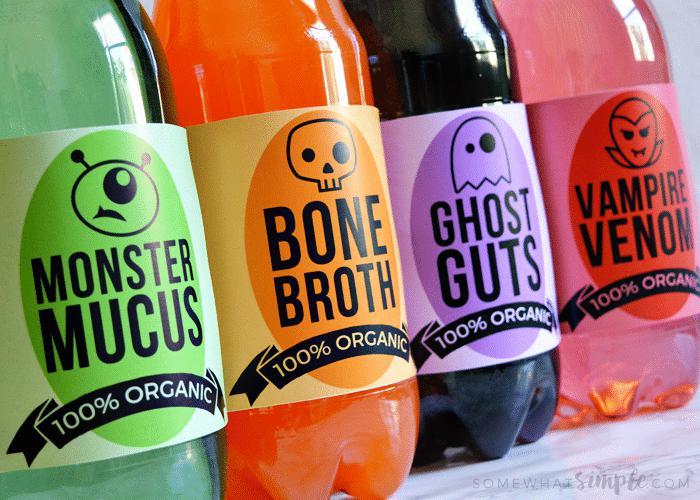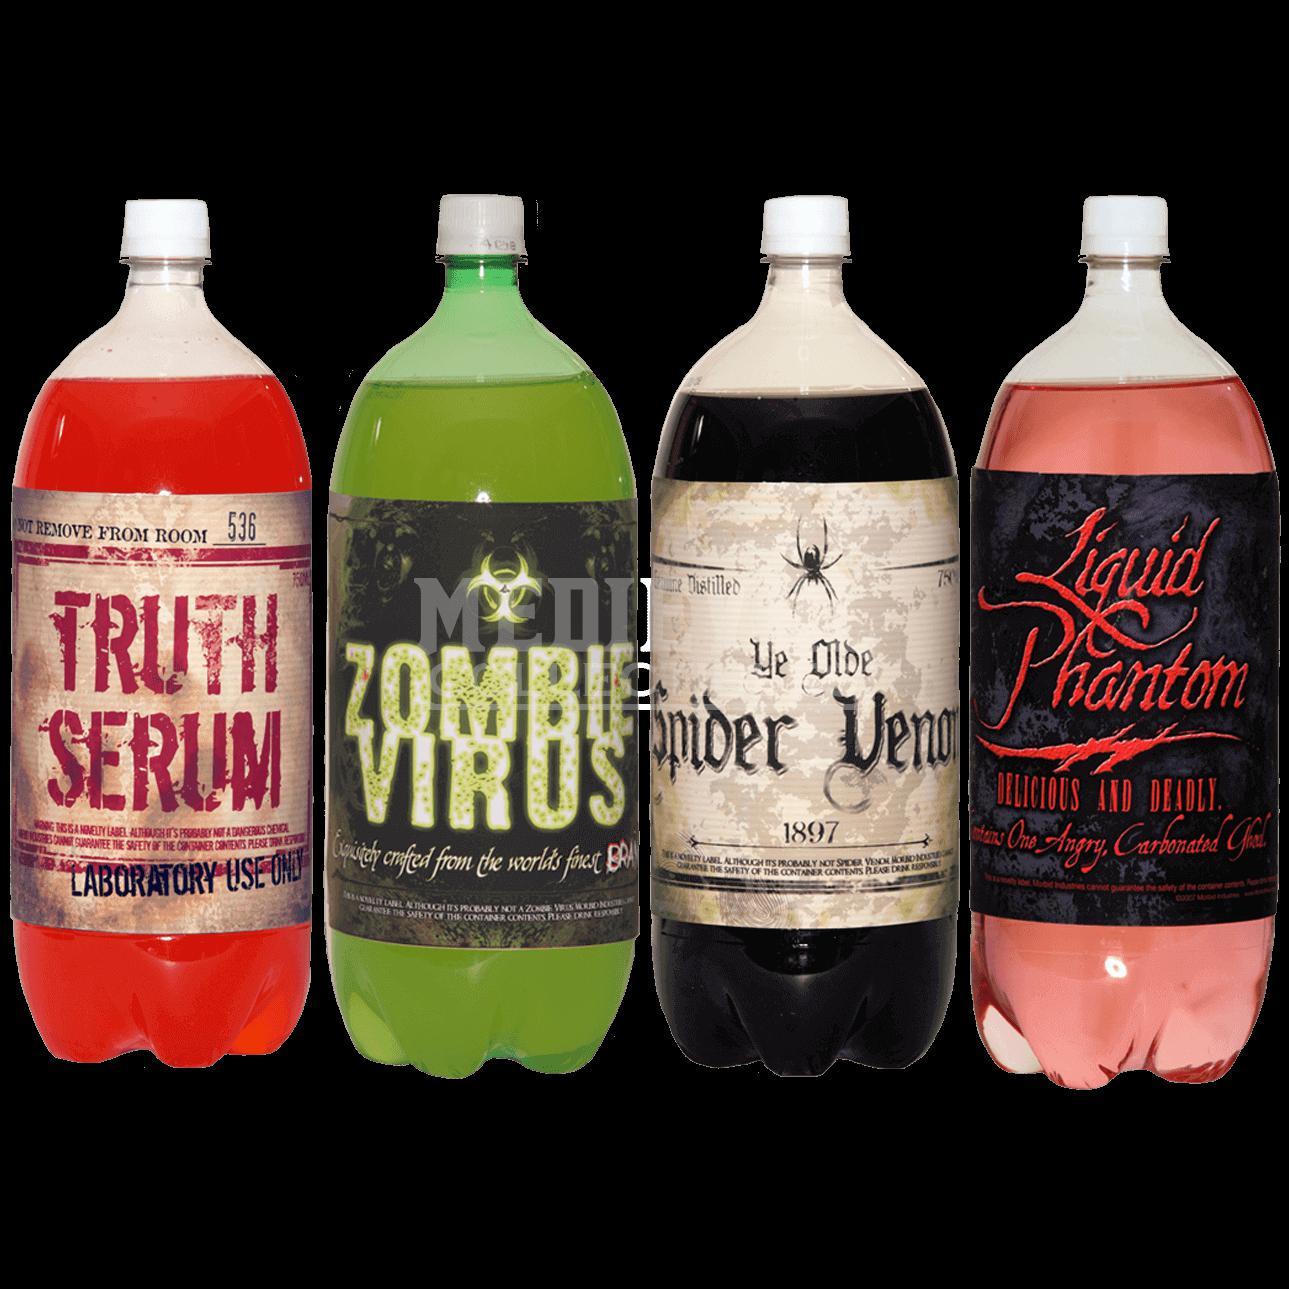The first image is the image on the left, the second image is the image on the right. Assess this claim about the two images: "There are only three bottles visible in one of the images.". Correct or not? Answer yes or no. No. The first image is the image on the left, the second image is the image on the right. Assess this claim about the two images: "The image on the left shows four bottles, each containing a different kind of an organic drink, each with a Halloween name.". Correct or not? Answer yes or no. Yes. 